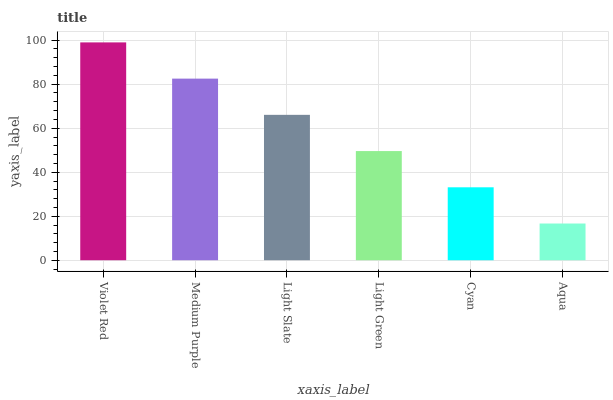Is Aqua the minimum?
Answer yes or no. Yes. Is Violet Red the maximum?
Answer yes or no. Yes. Is Medium Purple the minimum?
Answer yes or no. No. Is Medium Purple the maximum?
Answer yes or no. No. Is Violet Red greater than Medium Purple?
Answer yes or no. Yes. Is Medium Purple less than Violet Red?
Answer yes or no. Yes. Is Medium Purple greater than Violet Red?
Answer yes or no. No. Is Violet Red less than Medium Purple?
Answer yes or no. No. Is Light Slate the high median?
Answer yes or no. Yes. Is Light Green the low median?
Answer yes or no. Yes. Is Cyan the high median?
Answer yes or no. No. Is Cyan the low median?
Answer yes or no. No. 